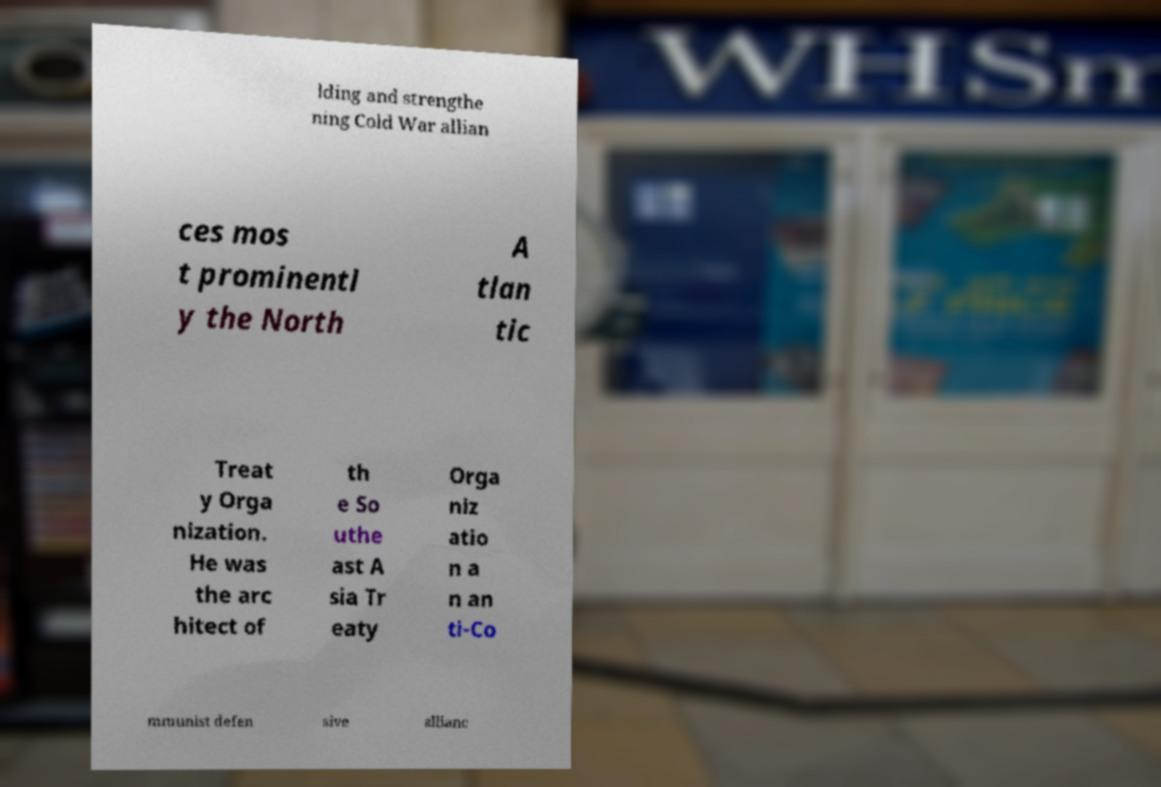I need the written content from this picture converted into text. Can you do that? lding and strengthe ning Cold War allian ces mos t prominentl y the North A tlan tic Treat y Orga nization. He was the arc hitect of th e So uthe ast A sia Tr eaty Orga niz atio n a n an ti-Co mmunist defen sive allianc 